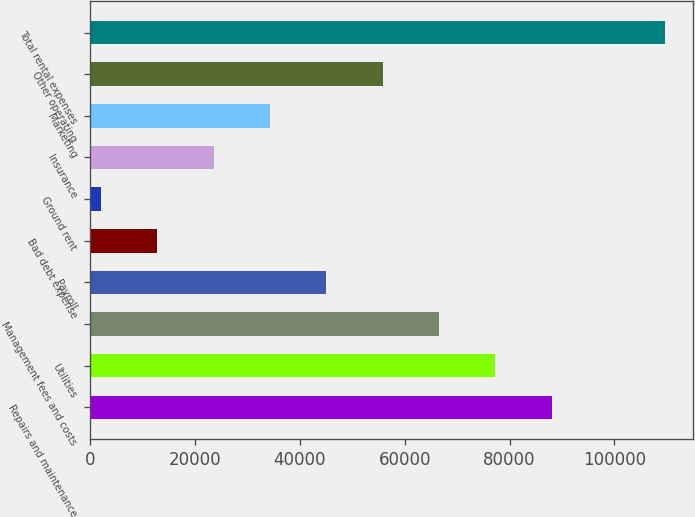Convert chart. <chart><loc_0><loc_0><loc_500><loc_500><bar_chart><fcel>Repairs and maintenance<fcel>Utilities<fcel>Management fees and costs<fcel>Payroll<fcel>Bad debt expense<fcel>Ground rent<fcel>Insurance<fcel>Marketing<fcel>Other operating<fcel>Total rental expenses<nl><fcel>88048.6<fcel>77298.4<fcel>66548.2<fcel>45047.8<fcel>12797.2<fcel>2047<fcel>23547.4<fcel>34297.6<fcel>55798<fcel>109549<nl></chart> 